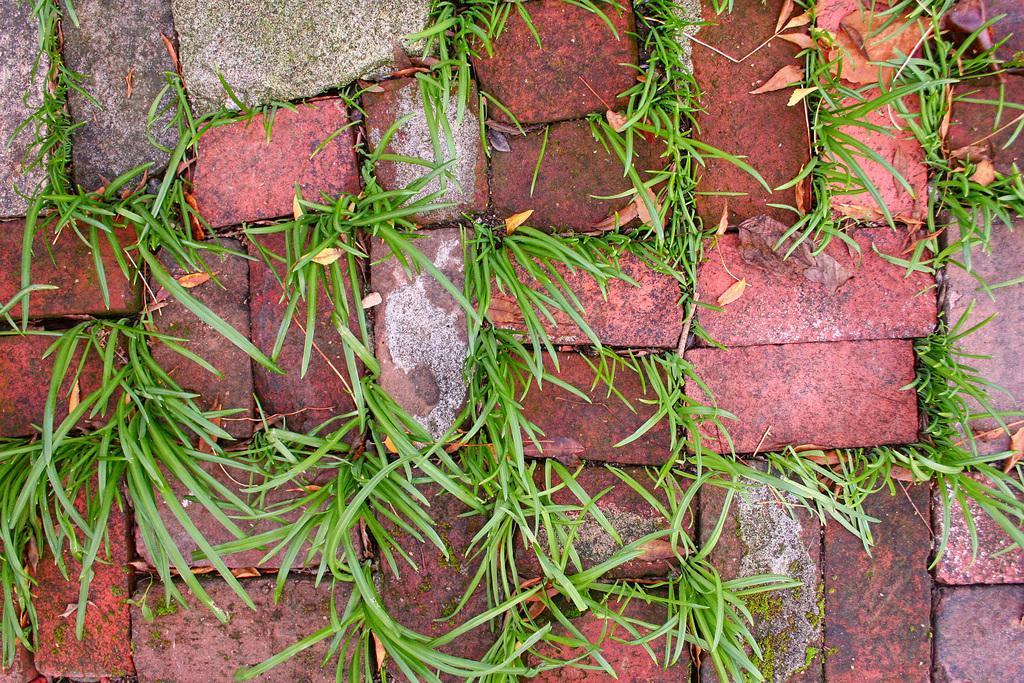How would you summarize this image in a sentence or two? In this picture we can see some bricks, we can also see grass and some leaves here. 